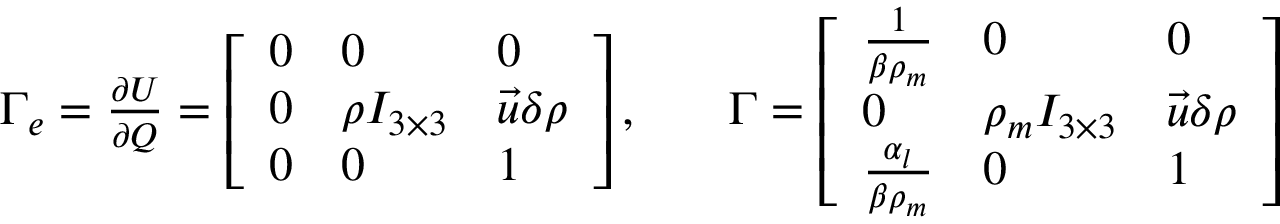<formula> <loc_0><loc_0><loc_500><loc_500>\begin{array} { r l r } { \Gamma _ { e } = \frac { \partial U } { \partial Q } = \left [ \begin{array} { l l l } { 0 } & { 0 } & { 0 } \\ { 0 } & { \rho I _ { 3 \times 3 } } & { \vec { u } \delta \rho } \\ { 0 } & { 0 } & { 1 } \end{array} \right ] , } & { \Gamma = \left [ \begin{array} { l l l } { \frac { 1 } { \beta \rho _ { m } } } & { 0 } & { 0 } \\ { 0 } & { \rho _ { m } I _ { 3 \times 3 } } & { \vec { u } \delta \rho } \\ { \frac { \alpha _ { l } } { \beta \rho _ { m } } } & { 0 } & { 1 } \end{array} \right ] } \end{array}</formula> 